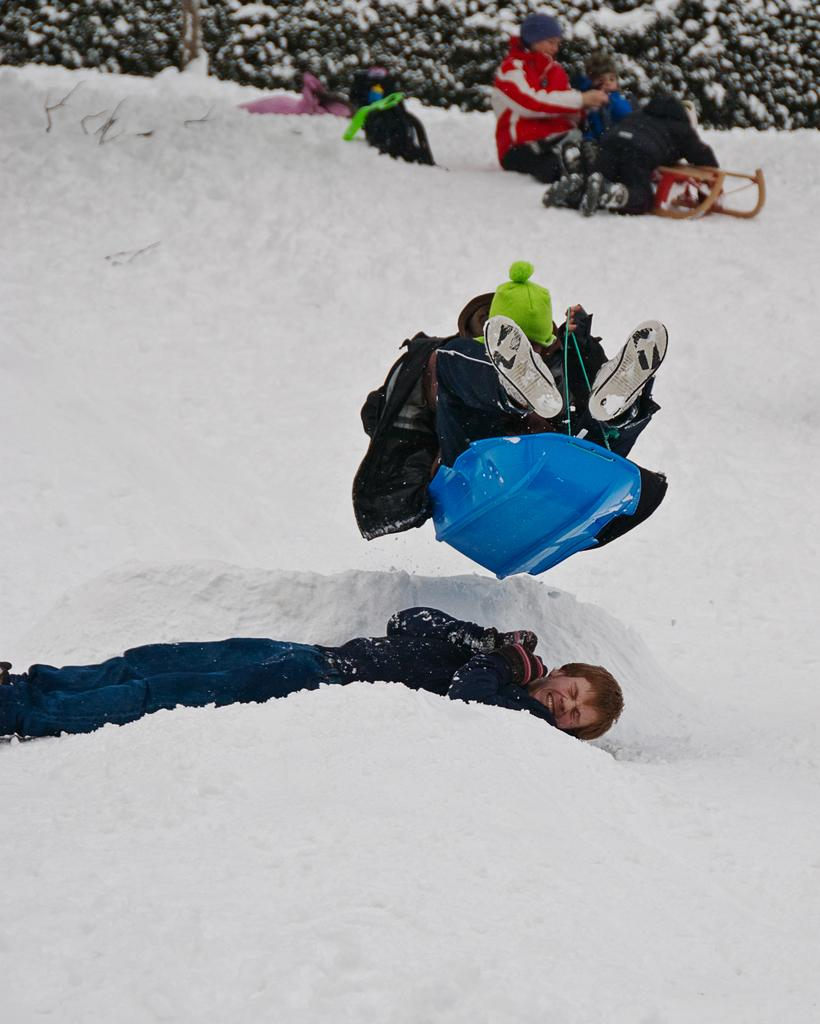How many people are in the image? There are people in the image, but the exact number is not specified. What are the people doing in the image? Some people are dying, jumping, and sitting in the image. What type of clothing are the people wearing? The people are wearing snow clothes in the image. What is the color of the snow in the image? The snow is white in color. What other natural elements can be seen in the image? There are leaves visible in the image. What type of industry is depicted in the image? There is no industry present in the image; it features people in snow clothes and a snowy environment. What is the plot of the story unfolding in the image? The image does not depict a story or plot; it simply shows people in various positions and a snowy landscape. 